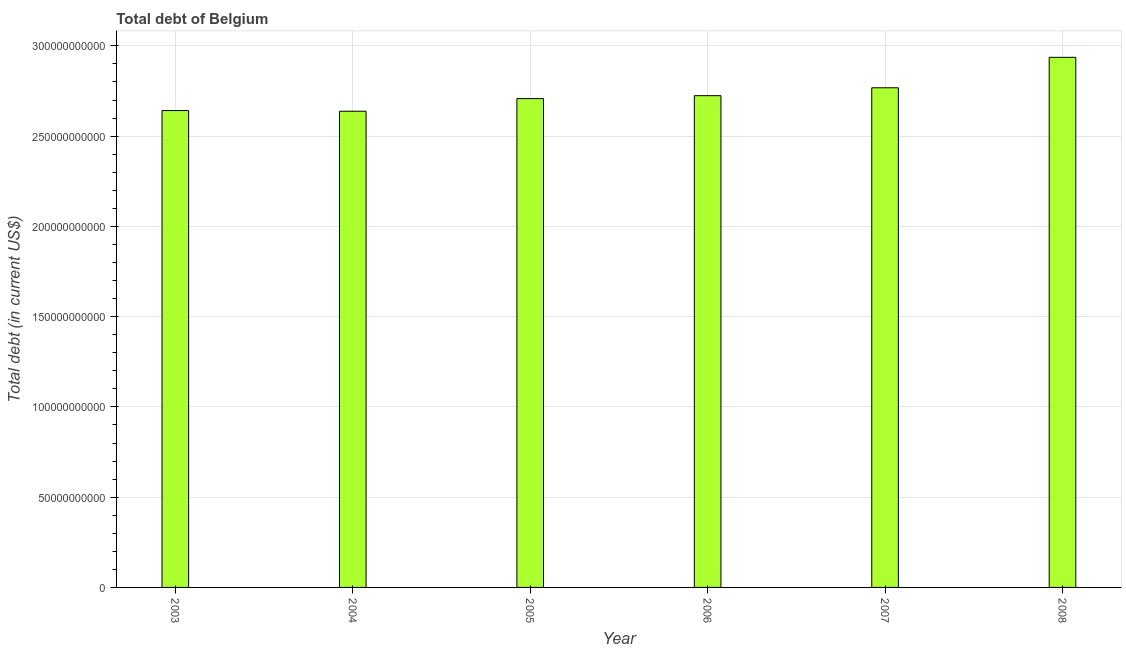Does the graph contain grids?
Provide a succinct answer. Yes. What is the title of the graph?
Ensure brevity in your answer.  Total debt of Belgium. What is the label or title of the X-axis?
Provide a short and direct response. Year. What is the label or title of the Y-axis?
Provide a succinct answer. Total debt (in current US$). What is the total debt in 2003?
Make the answer very short. 2.64e+11. Across all years, what is the maximum total debt?
Your response must be concise. 2.94e+11. Across all years, what is the minimum total debt?
Your response must be concise. 2.64e+11. In which year was the total debt maximum?
Your answer should be compact. 2008. In which year was the total debt minimum?
Keep it short and to the point. 2004. What is the sum of the total debt?
Provide a short and direct response. 1.64e+12. What is the difference between the total debt in 2003 and 2008?
Provide a succinct answer. -2.95e+1. What is the average total debt per year?
Your response must be concise. 2.74e+11. What is the median total debt?
Give a very brief answer. 2.72e+11. Is the total debt in 2004 less than that in 2006?
Keep it short and to the point. Yes. What is the difference between the highest and the second highest total debt?
Your answer should be very brief. 1.69e+1. Is the sum of the total debt in 2005 and 2006 greater than the maximum total debt across all years?
Ensure brevity in your answer.  Yes. What is the difference between the highest and the lowest total debt?
Provide a short and direct response. 2.99e+1. Are all the bars in the graph horizontal?
Give a very brief answer. No. What is the difference between two consecutive major ticks on the Y-axis?
Your answer should be compact. 5.00e+1. Are the values on the major ticks of Y-axis written in scientific E-notation?
Provide a succinct answer. No. What is the Total debt (in current US$) of 2003?
Make the answer very short. 2.64e+11. What is the Total debt (in current US$) of 2004?
Offer a terse response. 2.64e+11. What is the Total debt (in current US$) in 2005?
Your answer should be very brief. 2.71e+11. What is the Total debt (in current US$) of 2006?
Offer a terse response. 2.72e+11. What is the Total debt (in current US$) of 2007?
Ensure brevity in your answer.  2.77e+11. What is the Total debt (in current US$) in 2008?
Keep it short and to the point. 2.94e+11. What is the difference between the Total debt (in current US$) in 2003 and 2004?
Make the answer very short. 3.75e+08. What is the difference between the Total debt (in current US$) in 2003 and 2005?
Provide a short and direct response. -6.62e+09. What is the difference between the Total debt (in current US$) in 2003 and 2006?
Offer a terse response. -8.24e+09. What is the difference between the Total debt (in current US$) in 2003 and 2007?
Make the answer very short. -1.26e+1. What is the difference between the Total debt (in current US$) in 2003 and 2008?
Keep it short and to the point. -2.95e+1. What is the difference between the Total debt (in current US$) in 2004 and 2005?
Your response must be concise. -6.99e+09. What is the difference between the Total debt (in current US$) in 2004 and 2006?
Offer a very short reply. -8.62e+09. What is the difference between the Total debt (in current US$) in 2004 and 2007?
Your answer should be very brief. -1.30e+1. What is the difference between the Total debt (in current US$) in 2004 and 2008?
Offer a very short reply. -2.99e+1. What is the difference between the Total debt (in current US$) in 2005 and 2006?
Ensure brevity in your answer.  -1.63e+09. What is the difference between the Total debt (in current US$) in 2005 and 2007?
Ensure brevity in your answer.  -6.00e+09. What is the difference between the Total debt (in current US$) in 2005 and 2008?
Your response must be concise. -2.29e+1. What is the difference between the Total debt (in current US$) in 2006 and 2007?
Your answer should be compact. -4.37e+09. What is the difference between the Total debt (in current US$) in 2006 and 2008?
Offer a very short reply. -2.12e+1. What is the difference between the Total debt (in current US$) in 2007 and 2008?
Provide a short and direct response. -1.69e+1. What is the ratio of the Total debt (in current US$) in 2003 to that in 2004?
Provide a succinct answer. 1. What is the ratio of the Total debt (in current US$) in 2003 to that in 2006?
Provide a short and direct response. 0.97. What is the ratio of the Total debt (in current US$) in 2003 to that in 2007?
Offer a terse response. 0.95. What is the ratio of the Total debt (in current US$) in 2004 to that in 2007?
Provide a succinct answer. 0.95. What is the ratio of the Total debt (in current US$) in 2004 to that in 2008?
Make the answer very short. 0.9. What is the ratio of the Total debt (in current US$) in 2005 to that in 2006?
Your answer should be very brief. 0.99. What is the ratio of the Total debt (in current US$) in 2005 to that in 2007?
Keep it short and to the point. 0.98. What is the ratio of the Total debt (in current US$) in 2005 to that in 2008?
Ensure brevity in your answer.  0.92. What is the ratio of the Total debt (in current US$) in 2006 to that in 2007?
Keep it short and to the point. 0.98. What is the ratio of the Total debt (in current US$) in 2006 to that in 2008?
Provide a succinct answer. 0.93. What is the ratio of the Total debt (in current US$) in 2007 to that in 2008?
Offer a very short reply. 0.94. 